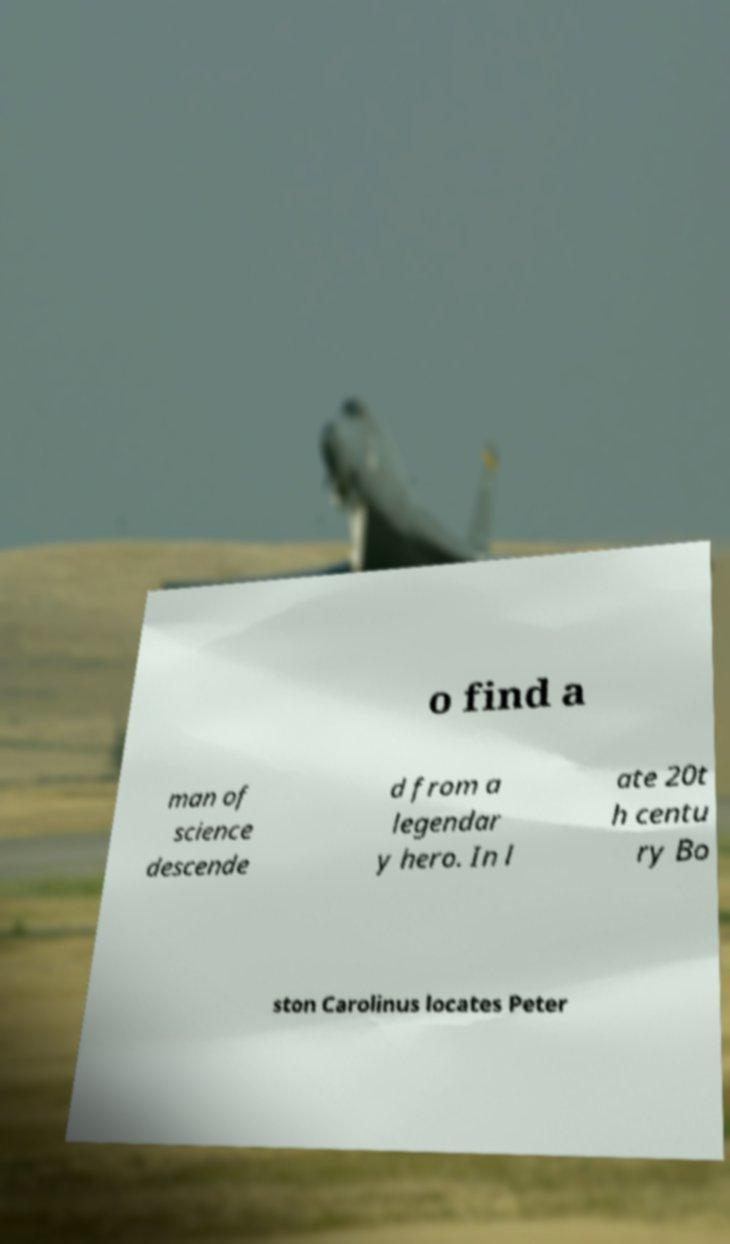Please read and relay the text visible in this image. What does it say? o find a man of science descende d from a legendar y hero. In l ate 20t h centu ry Bo ston Carolinus locates Peter 